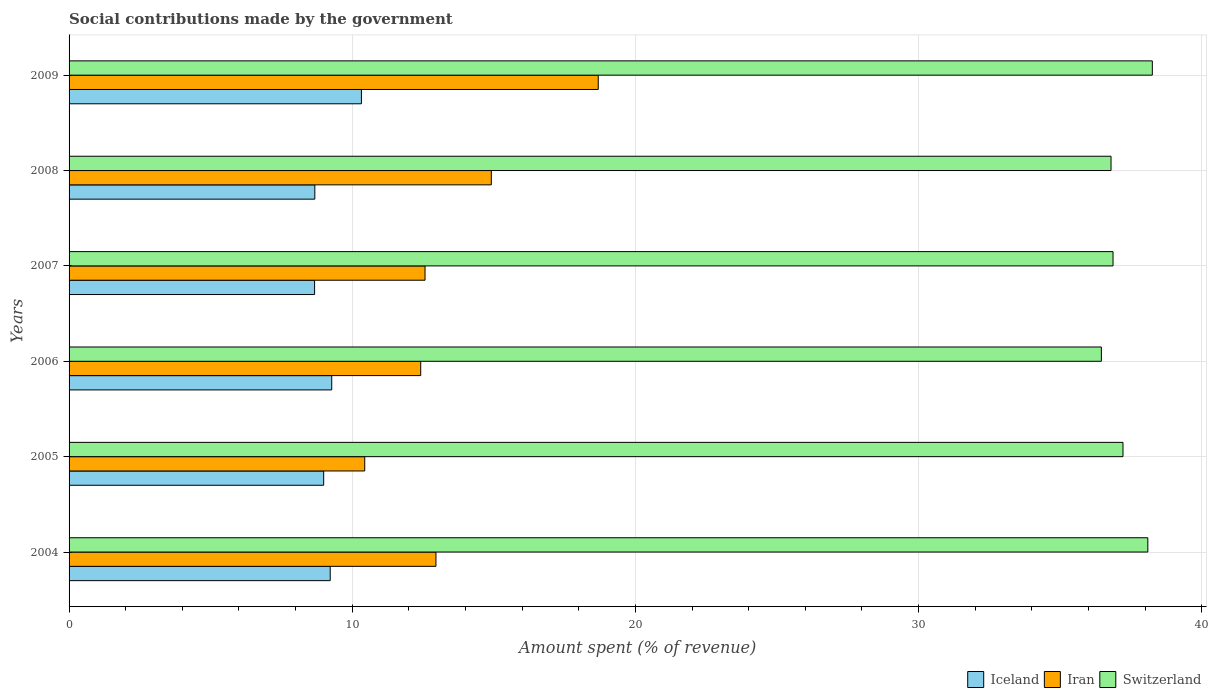How many different coloured bars are there?
Offer a very short reply. 3. Are the number of bars on each tick of the Y-axis equal?
Your response must be concise. Yes. How many bars are there on the 6th tick from the top?
Provide a short and direct response. 3. How many bars are there on the 1st tick from the bottom?
Your response must be concise. 3. What is the amount spent (in %) on social contributions in Iran in 2004?
Keep it short and to the point. 12.96. Across all years, what is the maximum amount spent (in %) on social contributions in Switzerland?
Give a very brief answer. 38.26. Across all years, what is the minimum amount spent (in %) on social contributions in Iran?
Provide a succinct answer. 10.44. What is the total amount spent (in %) on social contributions in Iran in the graph?
Offer a very short reply. 81.99. What is the difference between the amount spent (in %) on social contributions in Iran in 2005 and that in 2009?
Ensure brevity in your answer.  -8.25. What is the difference between the amount spent (in %) on social contributions in Switzerland in 2006 and the amount spent (in %) on social contributions in Iran in 2008?
Your answer should be very brief. 21.54. What is the average amount spent (in %) on social contributions in Iceland per year?
Provide a succinct answer. 9.19. In the year 2008, what is the difference between the amount spent (in %) on social contributions in Iran and amount spent (in %) on social contributions in Iceland?
Make the answer very short. 6.23. In how many years, is the amount spent (in %) on social contributions in Iran greater than 8 %?
Your response must be concise. 6. What is the ratio of the amount spent (in %) on social contributions in Iran in 2004 to that in 2006?
Make the answer very short. 1.04. Is the difference between the amount spent (in %) on social contributions in Iran in 2008 and 2009 greater than the difference between the amount spent (in %) on social contributions in Iceland in 2008 and 2009?
Give a very brief answer. No. What is the difference between the highest and the second highest amount spent (in %) on social contributions in Iceland?
Provide a succinct answer. 1.05. What is the difference between the highest and the lowest amount spent (in %) on social contributions in Switzerland?
Give a very brief answer. 1.8. In how many years, is the amount spent (in %) on social contributions in Iran greater than the average amount spent (in %) on social contributions in Iran taken over all years?
Offer a very short reply. 2. What does the 3rd bar from the top in 2005 represents?
Give a very brief answer. Iceland. What does the 3rd bar from the bottom in 2007 represents?
Offer a very short reply. Switzerland. Where does the legend appear in the graph?
Provide a succinct answer. Bottom right. How many legend labels are there?
Your answer should be compact. 3. How are the legend labels stacked?
Your answer should be compact. Horizontal. What is the title of the graph?
Your response must be concise. Social contributions made by the government. What is the label or title of the X-axis?
Offer a very short reply. Amount spent (% of revenue). What is the Amount spent (% of revenue) of Iceland in 2004?
Offer a terse response. 9.22. What is the Amount spent (% of revenue) in Iran in 2004?
Give a very brief answer. 12.96. What is the Amount spent (% of revenue) in Switzerland in 2004?
Provide a short and direct response. 38.1. What is the Amount spent (% of revenue) of Iceland in 2005?
Offer a terse response. 8.99. What is the Amount spent (% of revenue) of Iran in 2005?
Provide a succinct answer. 10.44. What is the Amount spent (% of revenue) of Switzerland in 2005?
Your answer should be very brief. 37.22. What is the Amount spent (% of revenue) in Iceland in 2006?
Offer a terse response. 9.28. What is the Amount spent (% of revenue) of Iran in 2006?
Offer a terse response. 12.42. What is the Amount spent (% of revenue) in Switzerland in 2006?
Ensure brevity in your answer.  36.46. What is the Amount spent (% of revenue) of Iceland in 2007?
Your answer should be very brief. 8.67. What is the Amount spent (% of revenue) in Iran in 2007?
Your answer should be very brief. 12.57. What is the Amount spent (% of revenue) of Switzerland in 2007?
Ensure brevity in your answer.  36.87. What is the Amount spent (% of revenue) in Iceland in 2008?
Keep it short and to the point. 8.68. What is the Amount spent (% of revenue) in Iran in 2008?
Your answer should be very brief. 14.91. What is the Amount spent (% of revenue) of Switzerland in 2008?
Provide a short and direct response. 36.8. What is the Amount spent (% of revenue) of Iceland in 2009?
Ensure brevity in your answer.  10.32. What is the Amount spent (% of revenue) of Iran in 2009?
Your answer should be very brief. 18.69. What is the Amount spent (% of revenue) of Switzerland in 2009?
Ensure brevity in your answer.  38.26. Across all years, what is the maximum Amount spent (% of revenue) in Iceland?
Keep it short and to the point. 10.32. Across all years, what is the maximum Amount spent (% of revenue) in Iran?
Your answer should be very brief. 18.69. Across all years, what is the maximum Amount spent (% of revenue) in Switzerland?
Give a very brief answer. 38.26. Across all years, what is the minimum Amount spent (% of revenue) of Iceland?
Give a very brief answer. 8.67. Across all years, what is the minimum Amount spent (% of revenue) in Iran?
Your response must be concise. 10.44. Across all years, what is the minimum Amount spent (% of revenue) in Switzerland?
Make the answer very short. 36.46. What is the total Amount spent (% of revenue) of Iceland in the graph?
Offer a terse response. 55.16. What is the total Amount spent (% of revenue) of Iran in the graph?
Keep it short and to the point. 81.99. What is the total Amount spent (% of revenue) in Switzerland in the graph?
Provide a succinct answer. 223.69. What is the difference between the Amount spent (% of revenue) of Iceland in 2004 and that in 2005?
Your response must be concise. 0.23. What is the difference between the Amount spent (% of revenue) of Iran in 2004 and that in 2005?
Your answer should be compact. 2.52. What is the difference between the Amount spent (% of revenue) in Switzerland in 2004 and that in 2005?
Your answer should be compact. 0.88. What is the difference between the Amount spent (% of revenue) of Iceland in 2004 and that in 2006?
Make the answer very short. -0.05. What is the difference between the Amount spent (% of revenue) of Iran in 2004 and that in 2006?
Give a very brief answer. 0.54. What is the difference between the Amount spent (% of revenue) in Switzerland in 2004 and that in 2006?
Ensure brevity in your answer.  1.64. What is the difference between the Amount spent (% of revenue) of Iceland in 2004 and that in 2007?
Make the answer very short. 0.55. What is the difference between the Amount spent (% of revenue) of Iran in 2004 and that in 2007?
Your answer should be compact. 0.39. What is the difference between the Amount spent (% of revenue) of Switzerland in 2004 and that in 2007?
Your response must be concise. 1.23. What is the difference between the Amount spent (% of revenue) of Iceland in 2004 and that in 2008?
Ensure brevity in your answer.  0.54. What is the difference between the Amount spent (% of revenue) of Iran in 2004 and that in 2008?
Keep it short and to the point. -1.96. What is the difference between the Amount spent (% of revenue) in Switzerland in 2004 and that in 2008?
Your answer should be very brief. 1.3. What is the difference between the Amount spent (% of revenue) of Iceland in 2004 and that in 2009?
Your answer should be compact. -1.1. What is the difference between the Amount spent (% of revenue) of Iran in 2004 and that in 2009?
Your response must be concise. -5.73. What is the difference between the Amount spent (% of revenue) of Switzerland in 2004 and that in 2009?
Your answer should be very brief. -0.16. What is the difference between the Amount spent (% of revenue) of Iceland in 2005 and that in 2006?
Keep it short and to the point. -0.28. What is the difference between the Amount spent (% of revenue) of Iran in 2005 and that in 2006?
Offer a terse response. -1.98. What is the difference between the Amount spent (% of revenue) in Switzerland in 2005 and that in 2006?
Your response must be concise. 0.76. What is the difference between the Amount spent (% of revenue) of Iceland in 2005 and that in 2007?
Keep it short and to the point. 0.32. What is the difference between the Amount spent (% of revenue) of Iran in 2005 and that in 2007?
Provide a succinct answer. -2.13. What is the difference between the Amount spent (% of revenue) in Switzerland in 2005 and that in 2007?
Give a very brief answer. 0.35. What is the difference between the Amount spent (% of revenue) of Iceland in 2005 and that in 2008?
Your answer should be very brief. 0.31. What is the difference between the Amount spent (% of revenue) in Iran in 2005 and that in 2008?
Provide a succinct answer. -4.47. What is the difference between the Amount spent (% of revenue) in Switzerland in 2005 and that in 2008?
Ensure brevity in your answer.  0.42. What is the difference between the Amount spent (% of revenue) of Iceland in 2005 and that in 2009?
Provide a succinct answer. -1.33. What is the difference between the Amount spent (% of revenue) in Iran in 2005 and that in 2009?
Make the answer very short. -8.25. What is the difference between the Amount spent (% of revenue) in Switzerland in 2005 and that in 2009?
Your answer should be very brief. -1.04. What is the difference between the Amount spent (% of revenue) of Iceland in 2006 and that in 2007?
Your answer should be very brief. 0.61. What is the difference between the Amount spent (% of revenue) of Iran in 2006 and that in 2007?
Offer a terse response. -0.15. What is the difference between the Amount spent (% of revenue) in Switzerland in 2006 and that in 2007?
Provide a short and direct response. -0.41. What is the difference between the Amount spent (% of revenue) of Iceland in 2006 and that in 2008?
Make the answer very short. 0.6. What is the difference between the Amount spent (% of revenue) in Iran in 2006 and that in 2008?
Your response must be concise. -2.49. What is the difference between the Amount spent (% of revenue) in Switzerland in 2006 and that in 2008?
Your answer should be compact. -0.34. What is the difference between the Amount spent (% of revenue) of Iceland in 2006 and that in 2009?
Your answer should be compact. -1.05. What is the difference between the Amount spent (% of revenue) of Iran in 2006 and that in 2009?
Ensure brevity in your answer.  -6.27. What is the difference between the Amount spent (% of revenue) of Switzerland in 2006 and that in 2009?
Offer a very short reply. -1.8. What is the difference between the Amount spent (% of revenue) in Iceland in 2007 and that in 2008?
Your answer should be very brief. -0.01. What is the difference between the Amount spent (% of revenue) of Iran in 2007 and that in 2008?
Ensure brevity in your answer.  -2.34. What is the difference between the Amount spent (% of revenue) of Switzerland in 2007 and that in 2008?
Offer a terse response. 0.07. What is the difference between the Amount spent (% of revenue) in Iceland in 2007 and that in 2009?
Your response must be concise. -1.65. What is the difference between the Amount spent (% of revenue) of Iran in 2007 and that in 2009?
Give a very brief answer. -6.12. What is the difference between the Amount spent (% of revenue) of Switzerland in 2007 and that in 2009?
Offer a terse response. -1.39. What is the difference between the Amount spent (% of revenue) in Iceland in 2008 and that in 2009?
Make the answer very short. -1.65. What is the difference between the Amount spent (% of revenue) of Iran in 2008 and that in 2009?
Offer a terse response. -3.78. What is the difference between the Amount spent (% of revenue) in Switzerland in 2008 and that in 2009?
Offer a terse response. -1.46. What is the difference between the Amount spent (% of revenue) of Iceland in 2004 and the Amount spent (% of revenue) of Iran in 2005?
Offer a terse response. -1.22. What is the difference between the Amount spent (% of revenue) in Iceland in 2004 and the Amount spent (% of revenue) in Switzerland in 2005?
Give a very brief answer. -28. What is the difference between the Amount spent (% of revenue) of Iran in 2004 and the Amount spent (% of revenue) of Switzerland in 2005?
Your answer should be very brief. -24.26. What is the difference between the Amount spent (% of revenue) in Iceland in 2004 and the Amount spent (% of revenue) in Iran in 2006?
Your answer should be very brief. -3.2. What is the difference between the Amount spent (% of revenue) in Iceland in 2004 and the Amount spent (% of revenue) in Switzerland in 2006?
Give a very brief answer. -27.23. What is the difference between the Amount spent (% of revenue) in Iran in 2004 and the Amount spent (% of revenue) in Switzerland in 2006?
Your answer should be compact. -23.5. What is the difference between the Amount spent (% of revenue) of Iceland in 2004 and the Amount spent (% of revenue) of Iran in 2007?
Your answer should be compact. -3.35. What is the difference between the Amount spent (% of revenue) in Iceland in 2004 and the Amount spent (% of revenue) in Switzerland in 2007?
Provide a short and direct response. -27.65. What is the difference between the Amount spent (% of revenue) in Iran in 2004 and the Amount spent (% of revenue) in Switzerland in 2007?
Give a very brief answer. -23.91. What is the difference between the Amount spent (% of revenue) of Iceland in 2004 and the Amount spent (% of revenue) of Iran in 2008?
Give a very brief answer. -5.69. What is the difference between the Amount spent (% of revenue) of Iceland in 2004 and the Amount spent (% of revenue) of Switzerland in 2008?
Provide a short and direct response. -27.57. What is the difference between the Amount spent (% of revenue) of Iran in 2004 and the Amount spent (% of revenue) of Switzerland in 2008?
Make the answer very short. -23.84. What is the difference between the Amount spent (% of revenue) in Iceland in 2004 and the Amount spent (% of revenue) in Iran in 2009?
Provide a succinct answer. -9.47. What is the difference between the Amount spent (% of revenue) of Iceland in 2004 and the Amount spent (% of revenue) of Switzerland in 2009?
Ensure brevity in your answer.  -29.03. What is the difference between the Amount spent (% of revenue) in Iran in 2004 and the Amount spent (% of revenue) in Switzerland in 2009?
Your answer should be very brief. -25.3. What is the difference between the Amount spent (% of revenue) in Iceland in 2005 and the Amount spent (% of revenue) in Iran in 2006?
Your response must be concise. -3.43. What is the difference between the Amount spent (% of revenue) in Iceland in 2005 and the Amount spent (% of revenue) in Switzerland in 2006?
Your response must be concise. -27.46. What is the difference between the Amount spent (% of revenue) in Iran in 2005 and the Amount spent (% of revenue) in Switzerland in 2006?
Provide a short and direct response. -26.01. What is the difference between the Amount spent (% of revenue) in Iceland in 2005 and the Amount spent (% of revenue) in Iran in 2007?
Provide a succinct answer. -3.58. What is the difference between the Amount spent (% of revenue) of Iceland in 2005 and the Amount spent (% of revenue) of Switzerland in 2007?
Provide a succinct answer. -27.88. What is the difference between the Amount spent (% of revenue) of Iran in 2005 and the Amount spent (% of revenue) of Switzerland in 2007?
Your response must be concise. -26.43. What is the difference between the Amount spent (% of revenue) of Iceland in 2005 and the Amount spent (% of revenue) of Iran in 2008?
Ensure brevity in your answer.  -5.92. What is the difference between the Amount spent (% of revenue) in Iceland in 2005 and the Amount spent (% of revenue) in Switzerland in 2008?
Your answer should be compact. -27.8. What is the difference between the Amount spent (% of revenue) of Iran in 2005 and the Amount spent (% of revenue) of Switzerland in 2008?
Your answer should be very brief. -26.36. What is the difference between the Amount spent (% of revenue) in Iceland in 2005 and the Amount spent (% of revenue) in Iran in 2009?
Provide a succinct answer. -9.7. What is the difference between the Amount spent (% of revenue) in Iceland in 2005 and the Amount spent (% of revenue) in Switzerland in 2009?
Offer a terse response. -29.26. What is the difference between the Amount spent (% of revenue) of Iran in 2005 and the Amount spent (% of revenue) of Switzerland in 2009?
Keep it short and to the point. -27.81. What is the difference between the Amount spent (% of revenue) of Iceland in 2006 and the Amount spent (% of revenue) of Iran in 2007?
Ensure brevity in your answer.  -3.29. What is the difference between the Amount spent (% of revenue) of Iceland in 2006 and the Amount spent (% of revenue) of Switzerland in 2007?
Keep it short and to the point. -27.59. What is the difference between the Amount spent (% of revenue) in Iran in 2006 and the Amount spent (% of revenue) in Switzerland in 2007?
Your response must be concise. -24.45. What is the difference between the Amount spent (% of revenue) of Iceland in 2006 and the Amount spent (% of revenue) of Iran in 2008?
Provide a succinct answer. -5.64. What is the difference between the Amount spent (% of revenue) in Iceland in 2006 and the Amount spent (% of revenue) in Switzerland in 2008?
Provide a short and direct response. -27.52. What is the difference between the Amount spent (% of revenue) of Iran in 2006 and the Amount spent (% of revenue) of Switzerland in 2008?
Give a very brief answer. -24.38. What is the difference between the Amount spent (% of revenue) of Iceland in 2006 and the Amount spent (% of revenue) of Iran in 2009?
Offer a very short reply. -9.41. What is the difference between the Amount spent (% of revenue) in Iceland in 2006 and the Amount spent (% of revenue) in Switzerland in 2009?
Make the answer very short. -28.98. What is the difference between the Amount spent (% of revenue) of Iran in 2006 and the Amount spent (% of revenue) of Switzerland in 2009?
Ensure brevity in your answer.  -25.84. What is the difference between the Amount spent (% of revenue) in Iceland in 2007 and the Amount spent (% of revenue) in Iran in 2008?
Provide a short and direct response. -6.24. What is the difference between the Amount spent (% of revenue) in Iceland in 2007 and the Amount spent (% of revenue) in Switzerland in 2008?
Make the answer very short. -28.13. What is the difference between the Amount spent (% of revenue) of Iran in 2007 and the Amount spent (% of revenue) of Switzerland in 2008?
Keep it short and to the point. -24.23. What is the difference between the Amount spent (% of revenue) in Iceland in 2007 and the Amount spent (% of revenue) in Iran in 2009?
Provide a succinct answer. -10.02. What is the difference between the Amount spent (% of revenue) of Iceland in 2007 and the Amount spent (% of revenue) of Switzerland in 2009?
Make the answer very short. -29.58. What is the difference between the Amount spent (% of revenue) of Iran in 2007 and the Amount spent (% of revenue) of Switzerland in 2009?
Offer a terse response. -25.68. What is the difference between the Amount spent (% of revenue) in Iceland in 2008 and the Amount spent (% of revenue) in Iran in 2009?
Ensure brevity in your answer.  -10.01. What is the difference between the Amount spent (% of revenue) of Iceland in 2008 and the Amount spent (% of revenue) of Switzerland in 2009?
Provide a succinct answer. -29.58. What is the difference between the Amount spent (% of revenue) in Iran in 2008 and the Amount spent (% of revenue) in Switzerland in 2009?
Your answer should be very brief. -23.34. What is the average Amount spent (% of revenue) of Iceland per year?
Keep it short and to the point. 9.19. What is the average Amount spent (% of revenue) of Iran per year?
Provide a succinct answer. 13.66. What is the average Amount spent (% of revenue) of Switzerland per year?
Ensure brevity in your answer.  37.28. In the year 2004, what is the difference between the Amount spent (% of revenue) of Iceland and Amount spent (% of revenue) of Iran?
Give a very brief answer. -3.73. In the year 2004, what is the difference between the Amount spent (% of revenue) of Iceland and Amount spent (% of revenue) of Switzerland?
Provide a short and direct response. -28.87. In the year 2004, what is the difference between the Amount spent (% of revenue) of Iran and Amount spent (% of revenue) of Switzerland?
Offer a terse response. -25.14. In the year 2005, what is the difference between the Amount spent (% of revenue) of Iceland and Amount spent (% of revenue) of Iran?
Your answer should be very brief. -1.45. In the year 2005, what is the difference between the Amount spent (% of revenue) of Iceland and Amount spent (% of revenue) of Switzerland?
Your answer should be very brief. -28.23. In the year 2005, what is the difference between the Amount spent (% of revenue) in Iran and Amount spent (% of revenue) in Switzerland?
Provide a succinct answer. -26.78. In the year 2006, what is the difference between the Amount spent (% of revenue) in Iceland and Amount spent (% of revenue) in Iran?
Make the answer very short. -3.14. In the year 2006, what is the difference between the Amount spent (% of revenue) of Iceland and Amount spent (% of revenue) of Switzerland?
Your answer should be very brief. -27.18. In the year 2006, what is the difference between the Amount spent (% of revenue) of Iran and Amount spent (% of revenue) of Switzerland?
Ensure brevity in your answer.  -24.04. In the year 2007, what is the difference between the Amount spent (% of revenue) of Iceland and Amount spent (% of revenue) of Iran?
Offer a terse response. -3.9. In the year 2007, what is the difference between the Amount spent (% of revenue) of Iceland and Amount spent (% of revenue) of Switzerland?
Your answer should be compact. -28.2. In the year 2007, what is the difference between the Amount spent (% of revenue) of Iran and Amount spent (% of revenue) of Switzerland?
Ensure brevity in your answer.  -24.3. In the year 2008, what is the difference between the Amount spent (% of revenue) of Iceland and Amount spent (% of revenue) of Iran?
Offer a terse response. -6.23. In the year 2008, what is the difference between the Amount spent (% of revenue) of Iceland and Amount spent (% of revenue) of Switzerland?
Keep it short and to the point. -28.12. In the year 2008, what is the difference between the Amount spent (% of revenue) of Iran and Amount spent (% of revenue) of Switzerland?
Your answer should be compact. -21.89. In the year 2009, what is the difference between the Amount spent (% of revenue) in Iceland and Amount spent (% of revenue) in Iran?
Make the answer very short. -8.36. In the year 2009, what is the difference between the Amount spent (% of revenue) of Iceland and Amount spent (% of revenue) of Switzerland?
Provide a succinct answer. -27.93. In the year 2009, what is the difference between the Amount spent (% of revenue) of Iran and Amount spent (% of revenue) of Switzerland?
Offer a terse response. -19.57. What is the ratio of the Amount spent (% of revenue) of Iceland in 2004 to that in 2005?
Your answer should be compact. 1.03. What is the ratio of the Amount spent (% of revenue) of Iran in 2004 to that in 2005?
Offer a very short reply. 1.24. What is the ratio of the Amount spent (% of revenue) in Switzerland in 2004 to that in 2005?
Give a very brief answer. 1.02. What is the ratio of the Amount spent (% of revenue) of Iceland in 2004 to that in 2006?
Your answer should be compact. 0.99. What is the ratio of the Amount spent (% of revenue) in Iran in 2004 to that in 2006?
Make the answer very short. 1.04. What is the ratio of the Amount spent (% of revenue) in Switzerland in 2004 to that in 2006?
Your answer should be very brief. 1.04. What is the ratio of the Amount spent (% of revenue) of Iceland in 2004 to that in 2007?
Offer a terse response. 1.06. What is the ratio of the Amount spent (% of revenue) in Iran in 2004 to that in 2007?
Provide a succinct answer. 1.03. What is the ratio of the Amount spent (% of revenue) of Iceland in 2004 to that in 2008?
Offer a terse response. 1.06. What is the ratio of the Amount spent (% of revenue) in Iran in 2004 to that in 2008?
Your answer should be compact. 0.87. What is the ratio of the Amount spent (% of revenue) of Switzerland in 2004 to that in 2008?
Your answer should be compact. 1.04. What is the ratio of the Amount spent (% of revenue) in Iceland in 2004 to that in 2009?
Provide a short and direct response. 0.89. What is the ratio of the Amount spent (% of revenue) in Iran in 2004 to that in 2009?
Your answer should be very brief. 0.69. What is the ratio of the Amount spent (% of revenue) in Switzerland in 2004 to that in 2009?
Provide a succinct answer. 1. What is the ratio of the Amount spent (% of revenue) in Iceland in 2005 to that in 2006?
Provide a succinct answer. 0.97. What is the ratio of the Amount spent (% of revenue) in Iran in 2005 to that in 2006?
Your answer should be compact. 0.84. What is the ratio of the Amount spent (% of revenue) of Iceland in 2005 to that in 2007?
Provide a succinct answer. 1.04. What is the ratio of the Amount spent (% of revenue) of Iran in 2005 to that in 2007?
Your answer should be very brief. 0.83. What is the ratio of the Amount spent (% of revenue) of Switzerland in 2005 to that in 2007?
Your answer should be very brief. 1.01. What is the ratio of the Amount spent (% of revenue) in Iceland in 2005 to that in 2008?
Make the answer very short. 1.04. What is the ratio of the Amount spent (% of revenue) of Iran in 2005 to that in 2008?
Your answer should be compact. 0.7. What is the ratio of the Amount spent (% of revenue) of Switzerland in 2005 to that in 2008?
Keep it short and to the point. 1.01. What is the ratio of the Amount spent (% of revenue) of Iceland in 2005 to that in 2009?
Make the answer very short. 0.87. What is the ratio of the Amount spent (% of revenue) in Iran in 2005 to that in 2009?
Ensure brevity in your answer.  0.56. What is the ratio of the Amount spent (% of revenue) in Switzerland in 2005 to that in 2009?
Offer a terse response. 0.97. What is the ratio of the Amount spent (% of revenue) of Iceland in 2006 to that in 2007?
Make the answer very short. 1.07. What is the ratio of the Amount spent (% of revenue) in Iran in 2006 to that in 2007?
Provide a succinct answer. 0.99. What is the ratio of the Amount spent (% of revenue) of Iceland in 2006 to that in 2008?
Your response must be concise. 1.07. What is the ratio of the Amount spent (% of revenue) in Iran in 2006 to that in 2008?
Provide a succinct answer. 0.83. What is the ratio of the Amount spent (% of revenue) of Switzerland in 2006 to that in 2008?
Ensure brevity in your answer.  0.99. What is the ratio of the Amount spent (% of revenue) of Iceland in 2006 to that in 2009?
Your answer should be compact. 0.9. What is the ratio of the Amount spent (% of revenue) of Iran in 2006 to that in 2009?
Provide a short and direct response. 0.66. What is the ratio of the Amount spent (% of revenue) in Switzerland in 2006 to that in 2009?
Your response must be concise. 0.95. What is the ratio of the Amount spent (% of revenue) of Iran in 2007 to that in 2008?
Keep it short and to the point. 0.84. What is the ratio of the Amount spent (% of revenue) in Iceland in 2007 to that in 2009?
Make the answer very short. 0.84. What is the ratio of the Amount spent (% of revenue) of Iran in 2007 to that in 2009?
Provide a short and direct response. 0.67. What is the ratio of the Amount spent (% of revenue) in Switzerland in 2007 to that in 2009?
Give a very brief answer. 0.96. What is the ratio of the Amount spent (% of revenue) in Iceland in 2008 to that in 2009?
Provide a short and direct response. 0.84. What is the ratio of the Amount spent (% of revenue) in Iran in 2008 to that in 2009?
Keep it short and to the point. 0.8. What is the ratio of the Amount spent (% of revenue) in Switzerland in 2008 to that in 2009?
Your response must be concise. 0.96. What is the difference between the highest and the second highest Amount spent (% of revenue) of Iceland?
Ensure brevity in your answer.  1.05. What is the difference between the highest and the second highest Amount spent (% of revenue) in Iran?
Offer a very short reply. 3.78. What is the difference between the highest and the second highest Amount spent (% of revenue) in Switzerland?
Your answer should be compact. 0.16. What is the difference between the highest and the lowest Amount spent (% of revenue) in Iceland?
Your response must be concise. 1.65. What is the difference between the highest and the lowest Amount spent (% of revenue) of Iran?
Your answer should be compact. 8.25. What is the difference between the highest and the lowest Amount spent (% of revenue) of Switzerland?
Your answer should be compact. 1.8. 